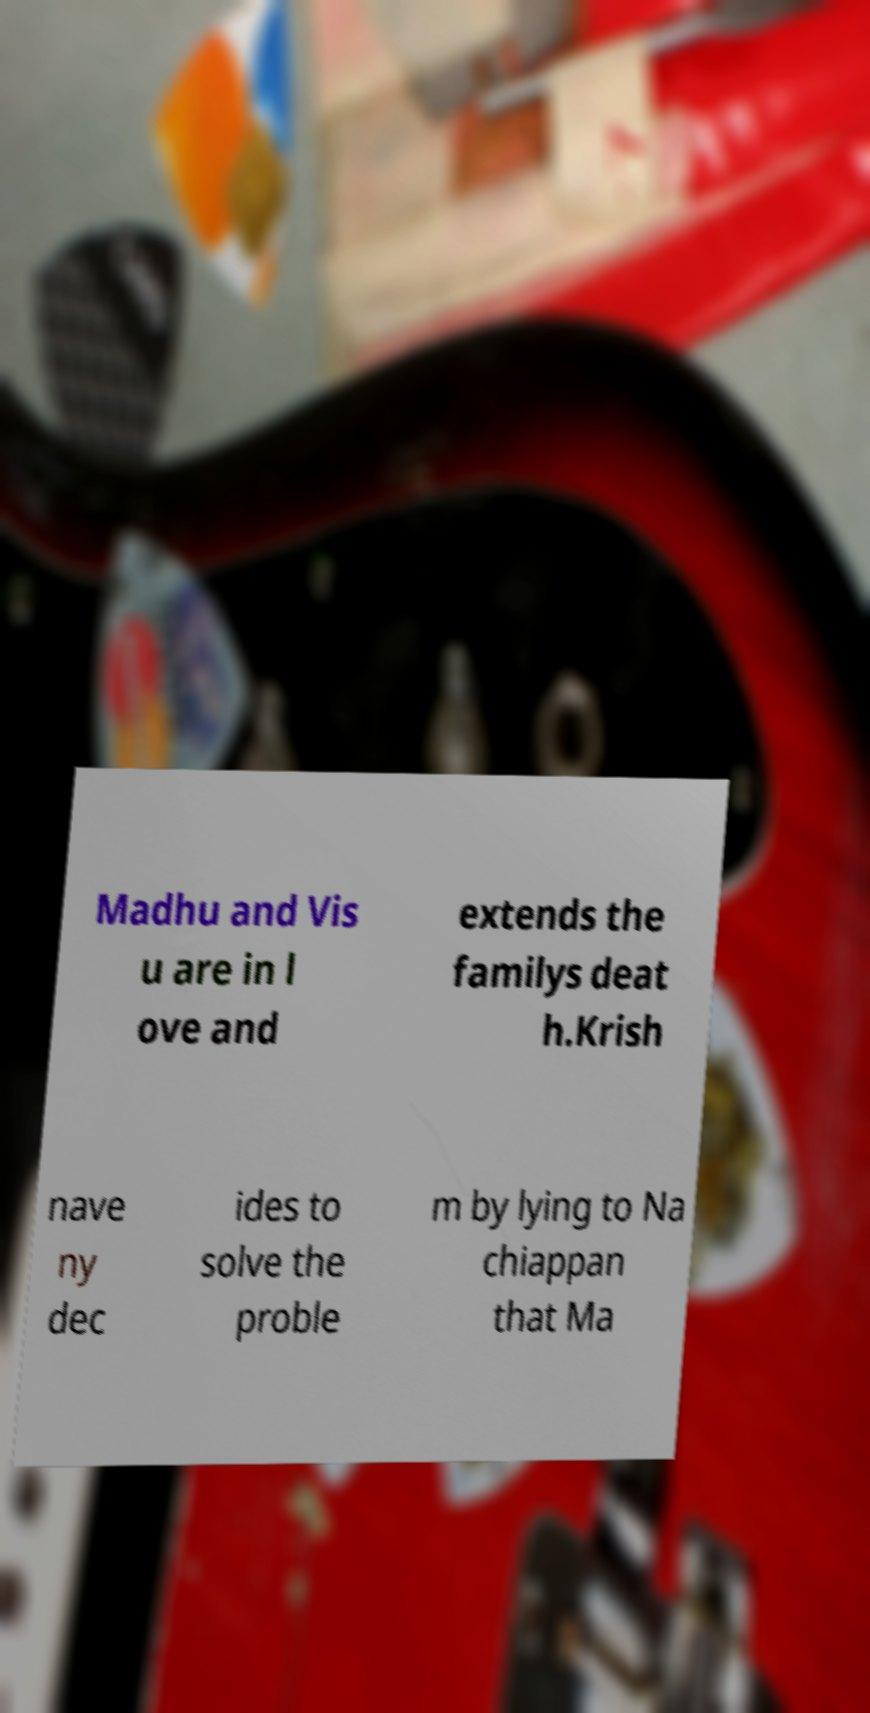For documentation purposes, I need the text within this image transcribed. Could you provide that? Madhu and Vis u are in l ove and extends the familys deat h.Krish nave ny dec ides to solve the proble m by lying to Na chiappan that Ma 